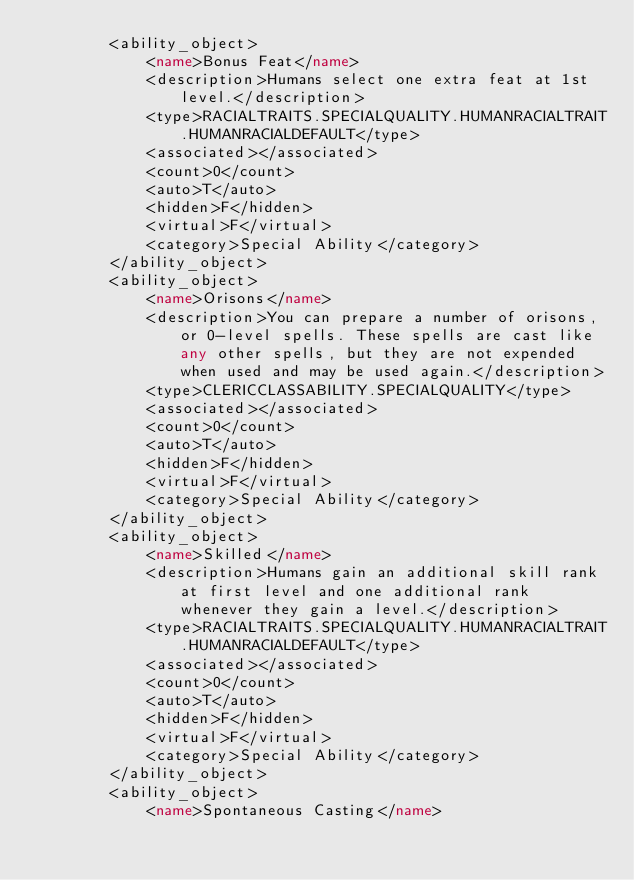Convert code to text. <code><loc_0><loc_0><loc_500><loc_500><_XML_>		<ability_object>
			<name>Bonus Feat</name>
			<description>Humans select one extra feat at 1st level.</description>
			<type>RACIALTRAITS.SPECIALQUALITY.HUMANRACIALTRAIT.HUMANRACIALDEFAULT</type>
			<associated></associated>
			<count>0</count>
			<auto>T</auto>
			<hidden>F</hidden>
			<virtual>F</virtual>
			<category>Special Ability</category>
		</ability_object>
		<ability_object>
			<name>Orisons</name>
			<description>You can prepare a number of orisons, or 0-level spells. These spells are cast like any other spells, but they are not expended when used and may be used again.</description>
			<type>CLERICCLASSABILITY.SPECIALQUALITY</type>
			<associated></associated>
			<count>0</count>
			<auto>T</auto>
			<hidden>F</hidden>
			<virtual>F</virtual>
			<category>Special Ability</category>
		</ability_object>
		<ability_object>
			<name>Skilled</name>
			<description>Humans gain an additional skill rank at first level and one additional rank whenever they gain a level.</description>
			<type>RACIALTRAITS.SPECIALQUALITY.HUMANRACIALTRAIT.HUMANRACIALDEFAULT</type>
			<associated></associated>
			<count>0</count>
			<auto>T</auto>
			<hidden>F</hidden>
			<virtual>F</virtual>
			<category>Special Ability</category>
		</ability_object>
		<ability_object>
			<name>Spontaneous Casting</name></code> 